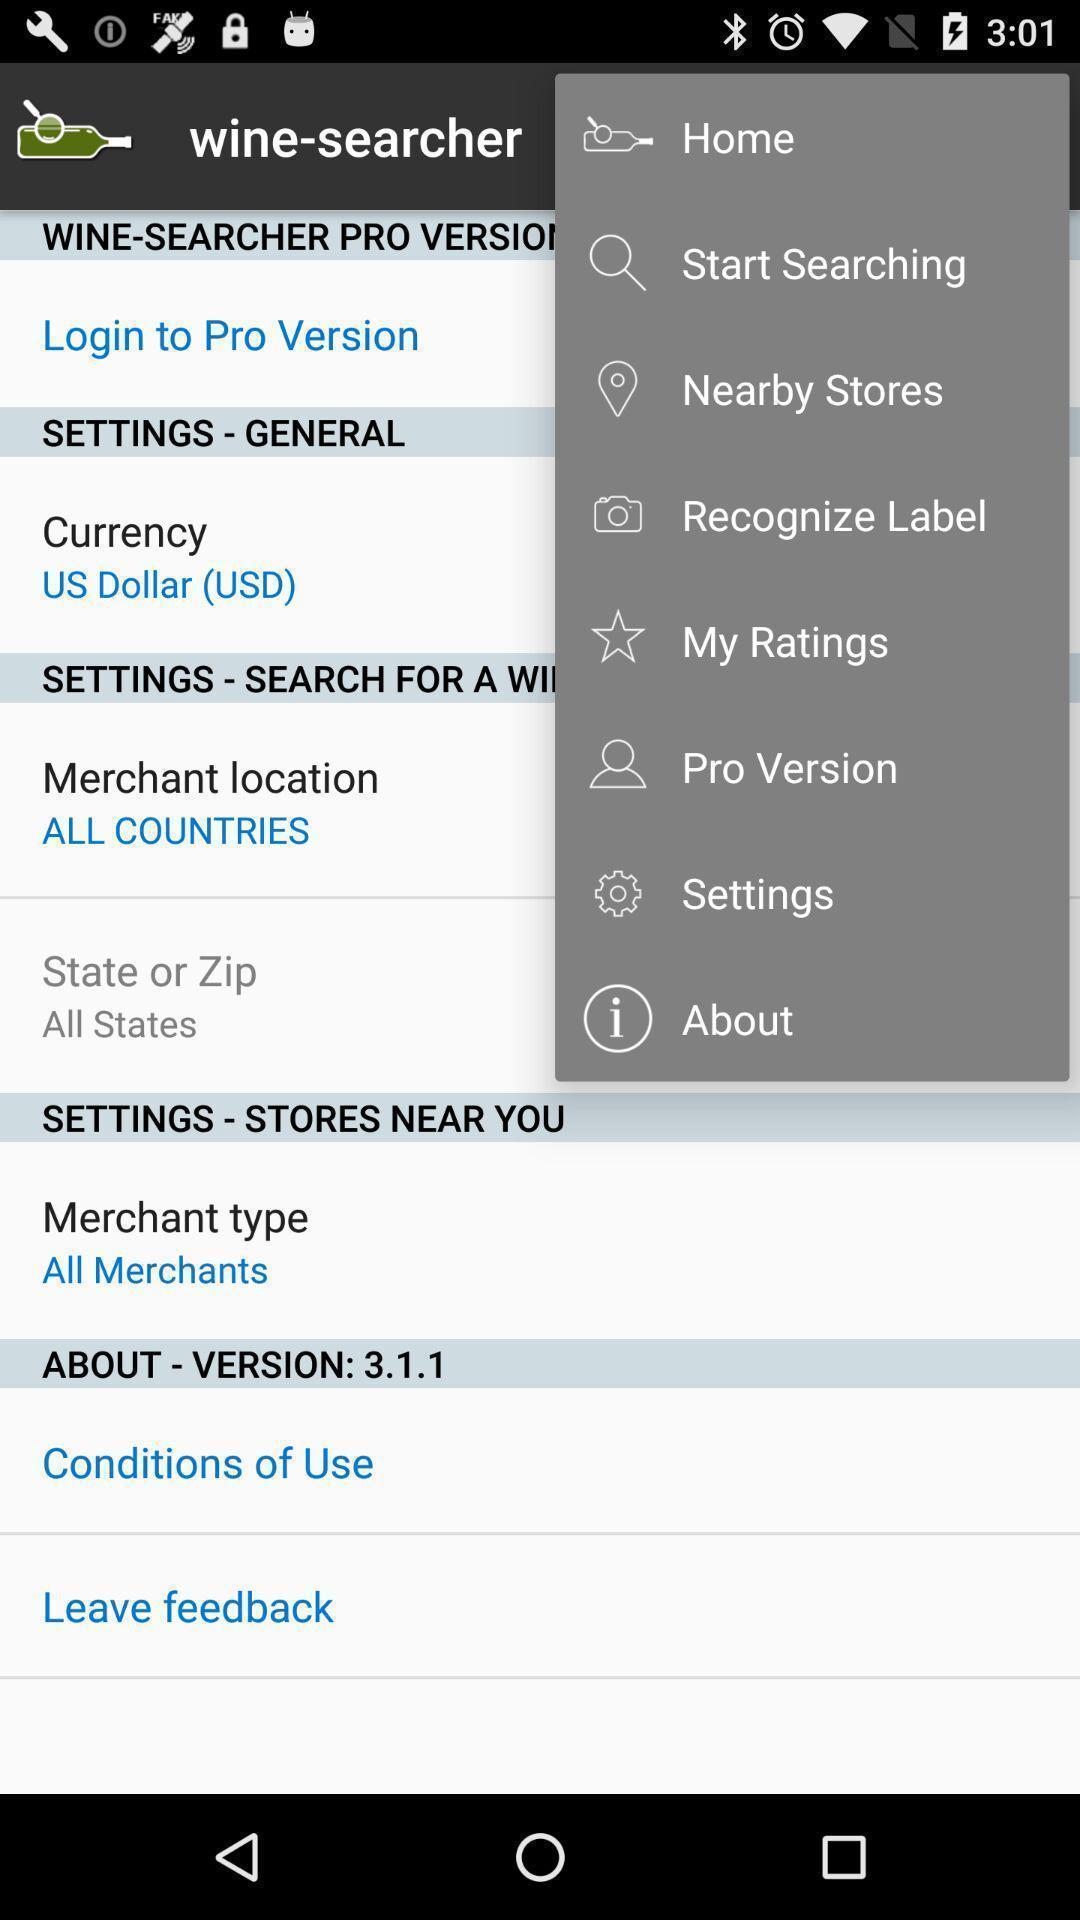Tell me what you see in this picture. Screen displaying menu of a drinking app. 